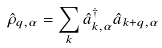Convert formula to latex. <formula><loc_0><loc_0><loc_500><loc_500>\hat { \rho } _ { q , \alpha } = \sum _ { k } \hat { a } _ { k , \alpha } ^ { \dagger } \hat { a } _ { k + q , \alpha }</formula> 